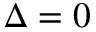Convert formula to latex. <formula><loc_0><loc_0><loc_500><loc_500>\Delta = 0</formula> 